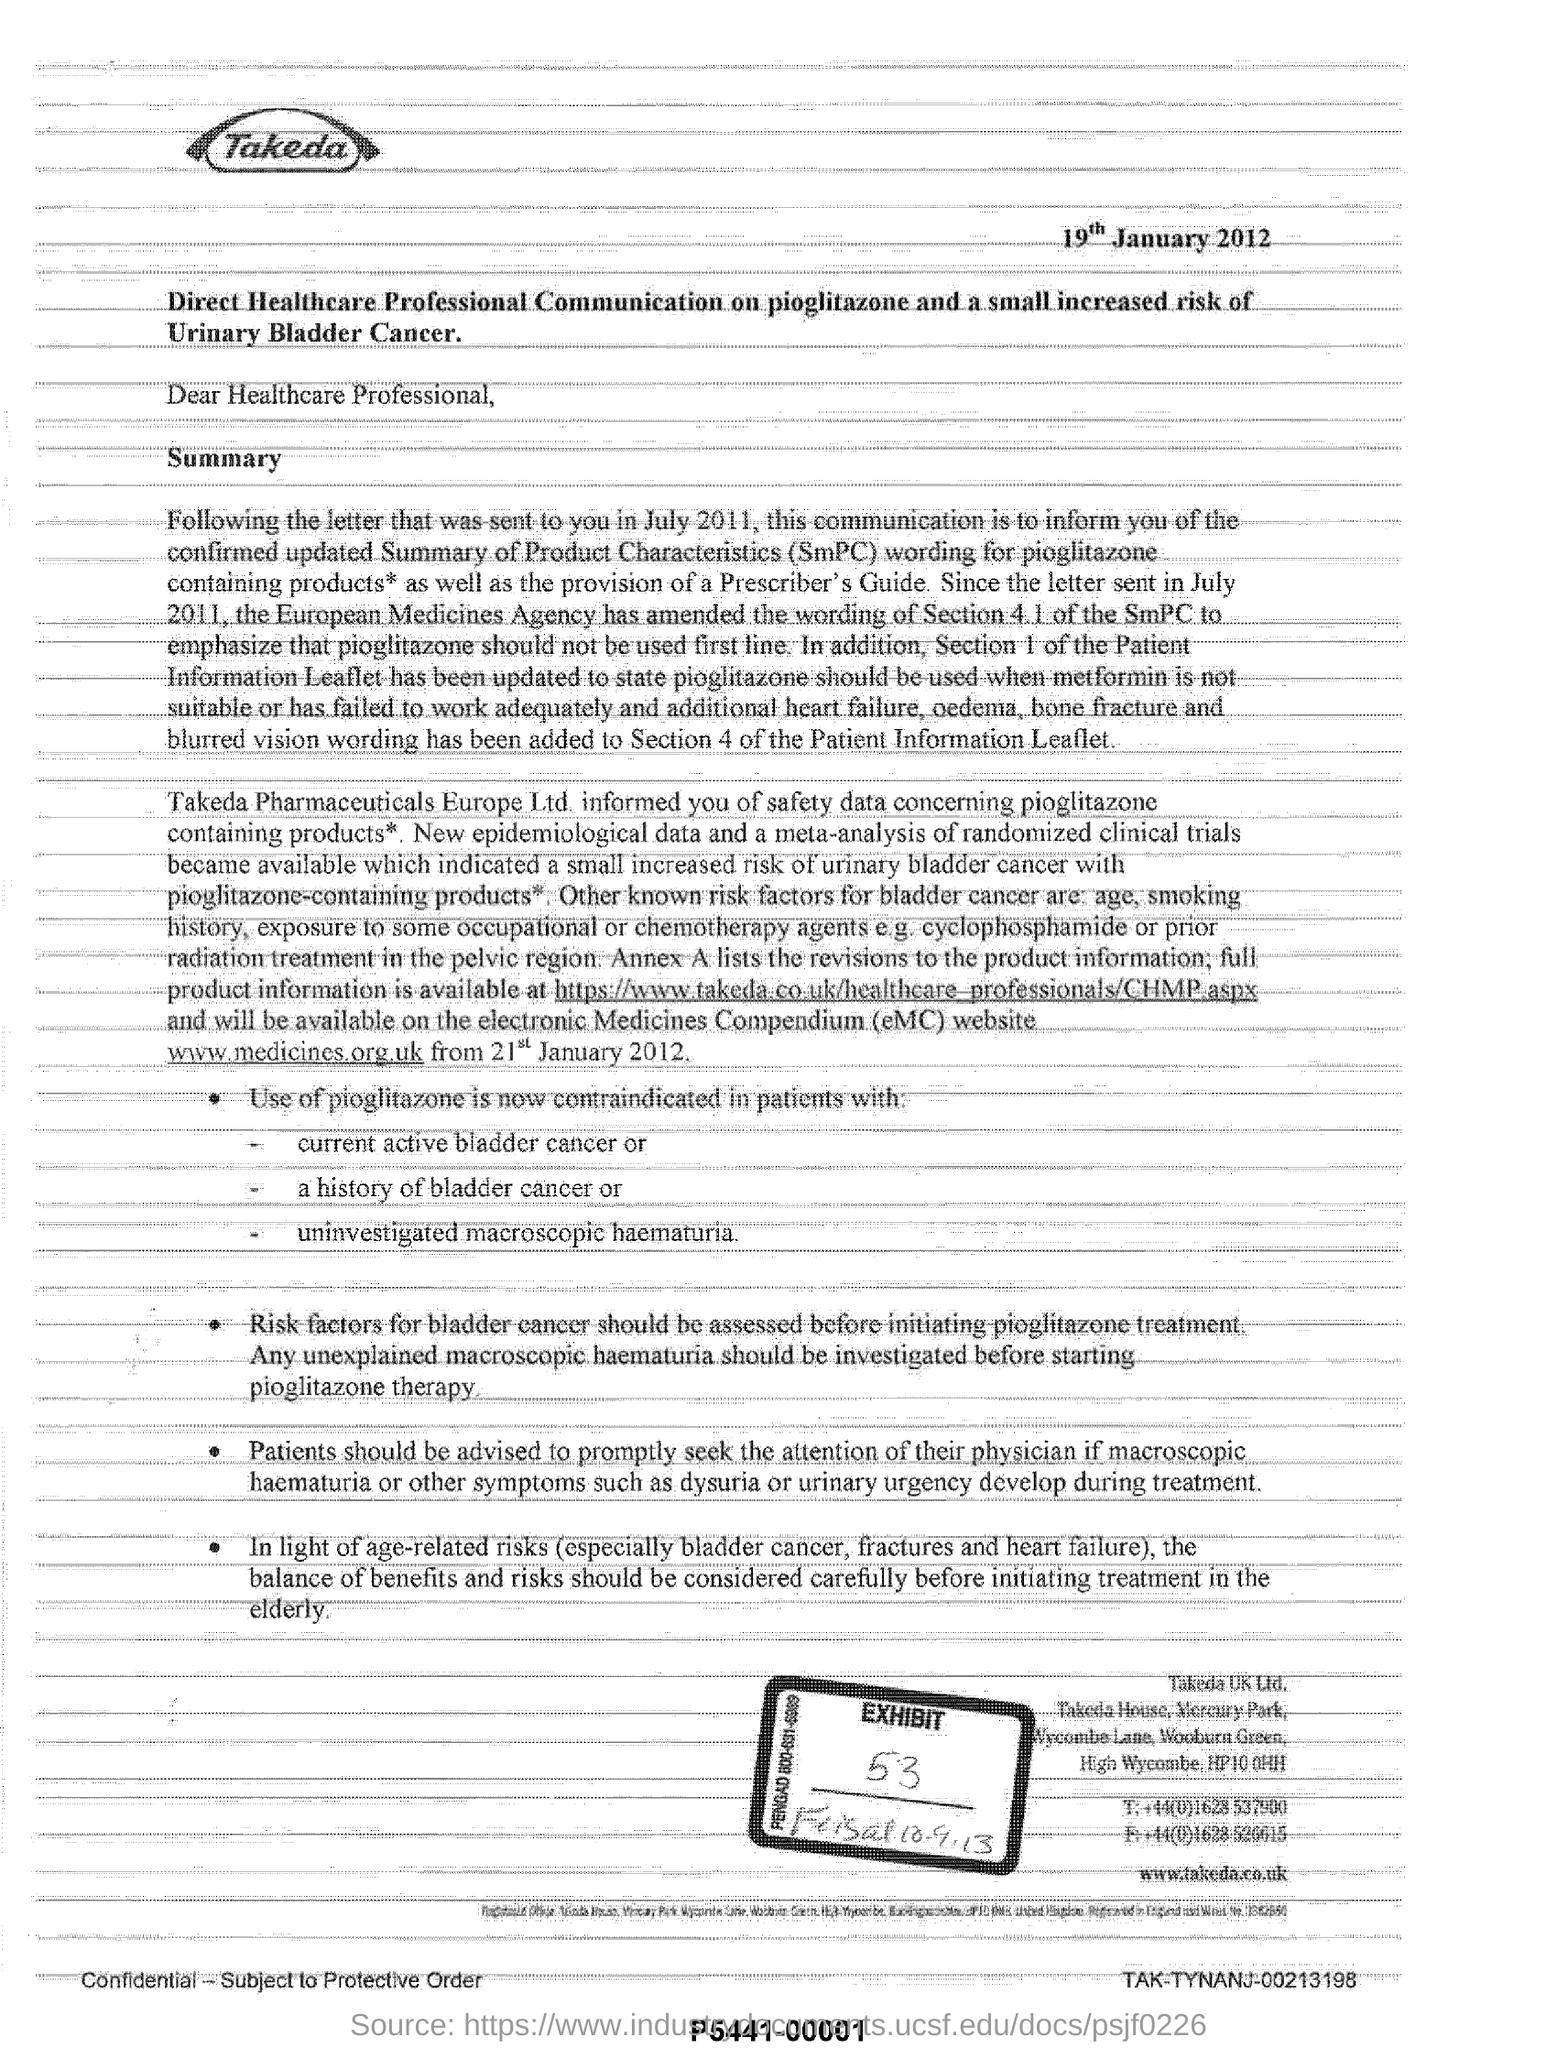Give some essential details in this illustration. This letter was written to a healthcare professional. The word written in bold at the top of the document is 'Takeda', The date mentioned is 19th January 2012. 